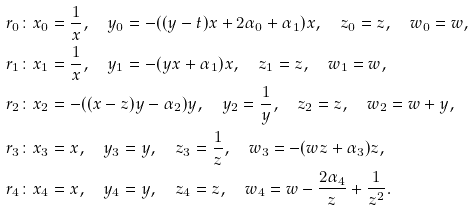Convert formula to latex. <formula><loc_0><loc_0><loc_500><loc_500>r _ { 0 } & \colon x _ { 0 } = \frac { 1 } { x } , \quad y _ { 0 } = - ( ( y - t ) x + 2 \alpha _ { 0 } + \alpha _ { 1 } ) x , \quad z _ { 0 } = z , \quad w _ { 0 } = w , \\ r _ { 1 } & \colon x _ { 1 } = \frac { 1 } { x } , \quad y _ { 1 } = - ( y x + \alpha _ { 1 } ) x , \quad z _ { 1 } = z , \quad w _ { 1 } = w , \\ r _ { 2 } & \colon x _ { 2 } = - ( ( x - z ) y - \alpha _ { 2 } ) y , \quad y _ { 2 } = \frac { 1 } { y } , \quad z _ { 2 } = z , \quad w _ { 2 } = w + y , \\ r _ { 3 } & \colon x _ { 3 } = x , \quad y _ { 3 } = y , \quad z _ { 3 } = \frac { 1 } { z } , \quad w _ { 3 } = - ( w z + \alpha _ { 3 } ) z , \\ r _ { 4 } & \colon x _ { 4 } = x , \quad y _ { 4 } = y , \quad z _ { 4 } = z , \quad w _ { 4 } = w - \frac { 2 \alpha _ { 4 } } { z } + \frac { 1 } { z ^ { 2 } } .</formula> 